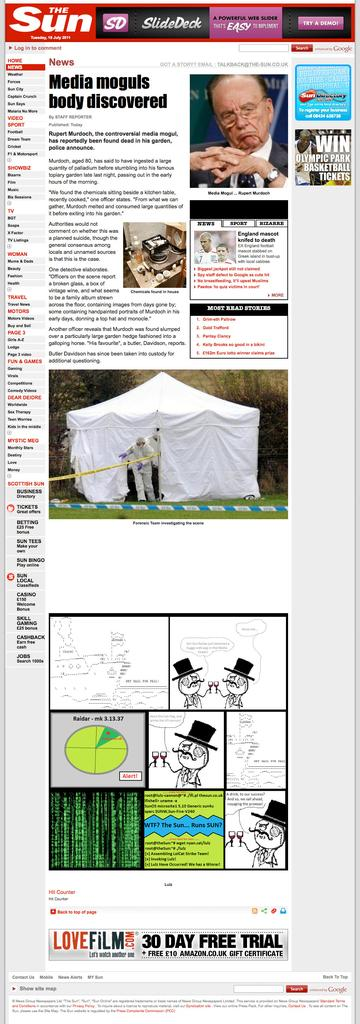What is the main object in the image? There is a magazine in the image. What can be found inside the magazine? The magazine contains information and images. What is located on top of the magazine? There is an advertisement on top of the magazine. What is visible in the sky in the image? The sun is observable in the image. What type of pipe is visible in the image? There is no pipe present in the image. How does the quartz contribute to the health of the person in the picture? There is no quartz or person present in the image, so it is not possible to determine any contribution to health. 